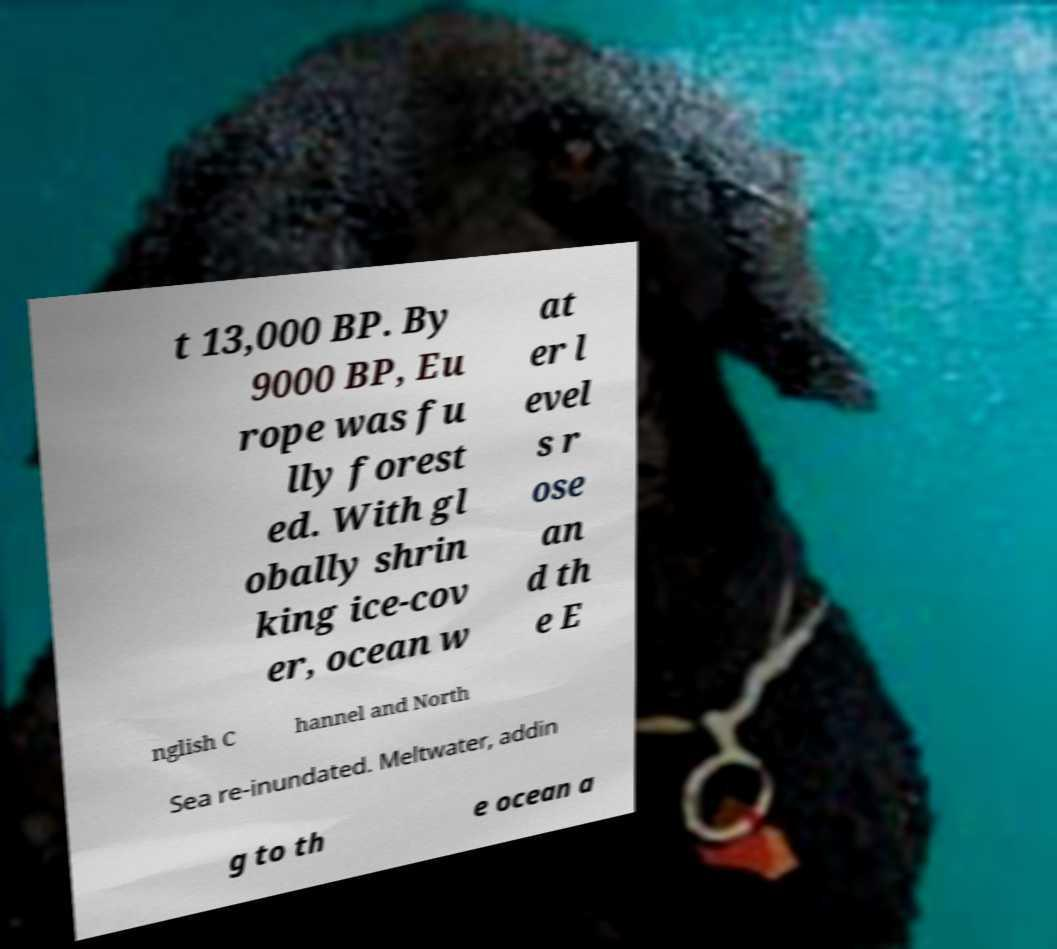I need the written content from this picture converted into text. Can you do that? t 13,000 BP. By 9000 BP, Eu rope was fu lly forest ed. With gl obally shrin king ice-cov er, ocean w at er l evel s r ose an d th e E nglish C hannel and North Sea re-inundated. Meltwater, addin g to th e ocean a 